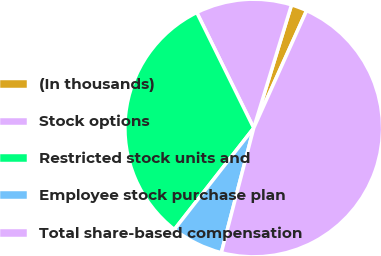Convert chart. <chart><loc_0><loc_0><loc_500><loc_500><pie_chart><fcel>(In thousands)<fcel>Stock options<fcel>Restricted stock units and<fcel>Employee stock purchase plan<fcel>Total share-based compensation<nl><fcel>1.99%<fcel>12.03%<fcel>32.15%<fcel>6.52%<fcel>47.32%<nl></chart> 